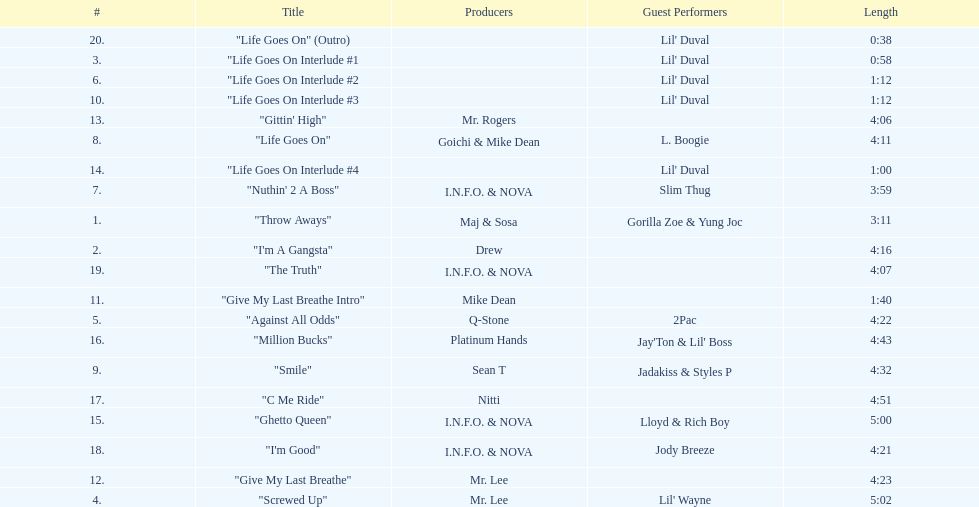What is the total number of tracks on the album? 20. 